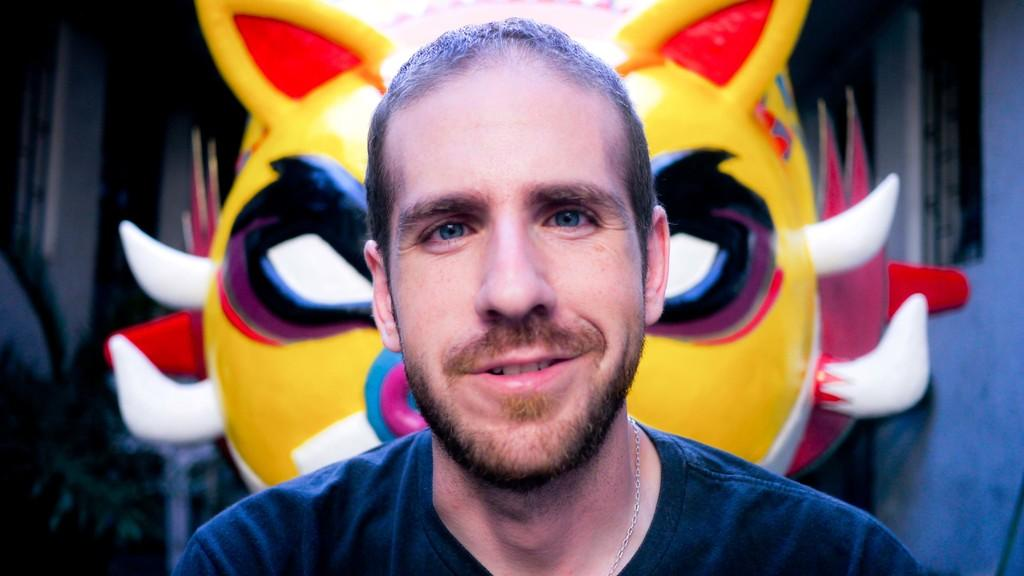What is the main subject of the image? There is a man in the image. What is the man wearing? The man is wearing a t-shirt. Are there any accessories visible on the man? Yes, the man has a chain around his neck. What can be seen in the background of the image? There are two colorful things in the background. How would you describe the lighting in the image? The image appears to be a bit dark. What type of mass is being held at the gate in the image? There is no mass or gate present in the image; it features a man wearing a t-shirt and a chain around his neck, with a dark background and two colorful things. 